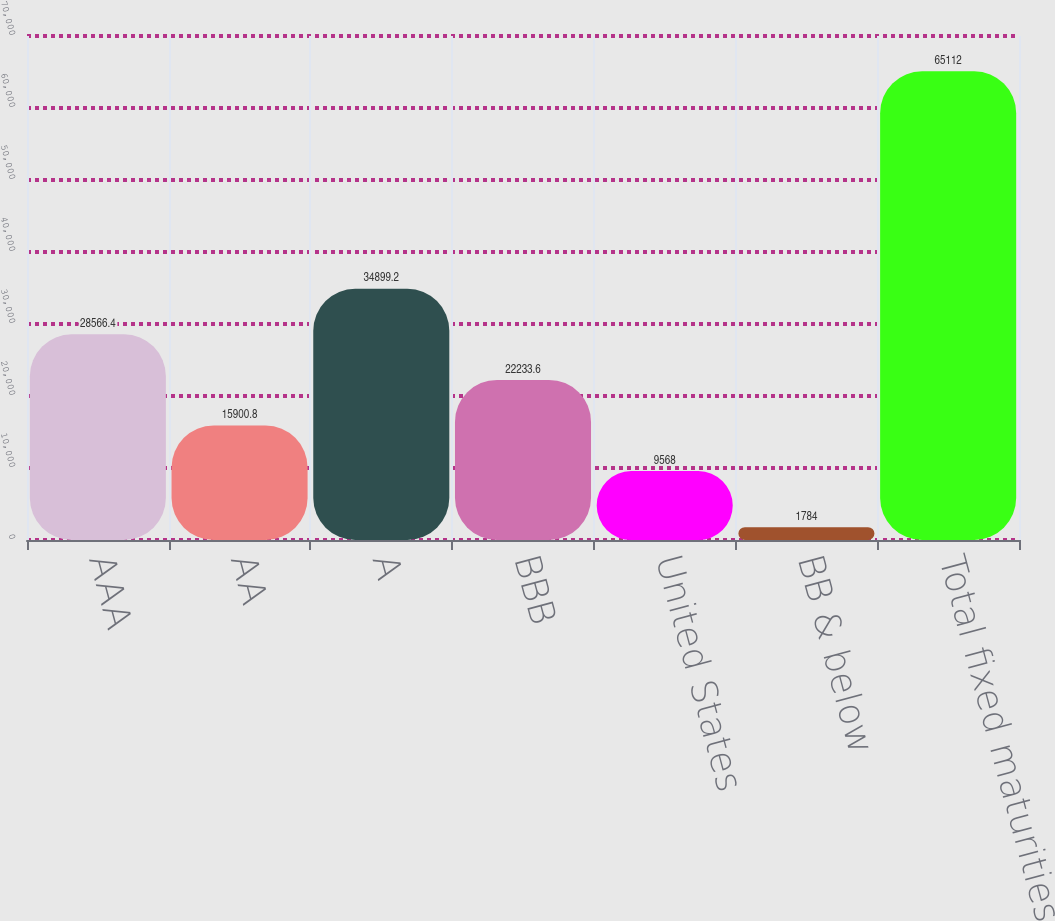Convert chart to OTSL. <chart><loc_0><loc_0><loc_500><loc_500><bar_chart><fcel>AAA<fcel>AA<fcel>A<fcel>BBB<fcel>United States<fcel>BB & below<fcel>Total fixed maturities<nl><fcel>28566.4<fcel>15900.8<fcel>34899.2<fcel>22233.6<fcel>9568<fcel>1784<fcel>65112<nl></chart> 